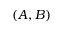Convert formula to latex. <formula><loc_0><loc_0><loc_500><loc_500>( A , B )</formula> 